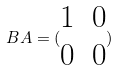Convert formula to latex. <formula><loc_0><loc_0><loc_500><loc_500>B A = ( \begin{matrix} 1 & 0 \\ 0 & 0 \end{matrix} )</formula> 